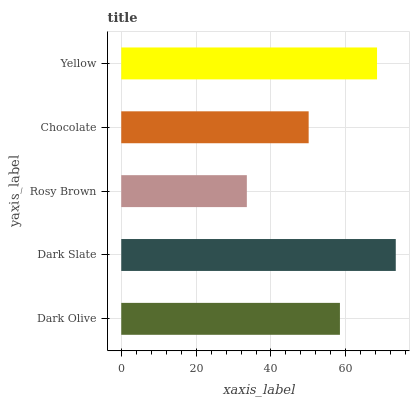Is Rosy Brown the minimum?
Answer yes or no. Yes. Is Dark Slate the maximum?
Answer yes or no. Yes. Is Dark Slate the minimum?
Answer yes or no. No. Is Rosy Brown the maximum?
Answer yes or no. No. Is Dark Slate greater than Rosy Brown?
Answer yes or no. Yes. Is Rosy Brown less than Dark Slate?
Answer yes or no. Yes. Is Rosy Brown greater than Dark Slate?
Answer yes or no. No. Is Dark Slate less than Rosy Brown?
Answer yes or no. No. Is Dark Olive the high median?
Answer yes or no. Yes. Is Dark Olive the low median?
Answer yes or no. Yes. Is Dark Slate the high median?
Answer yes or no. No. Is Dark Slate the low median?
Answer yes or no. No. 